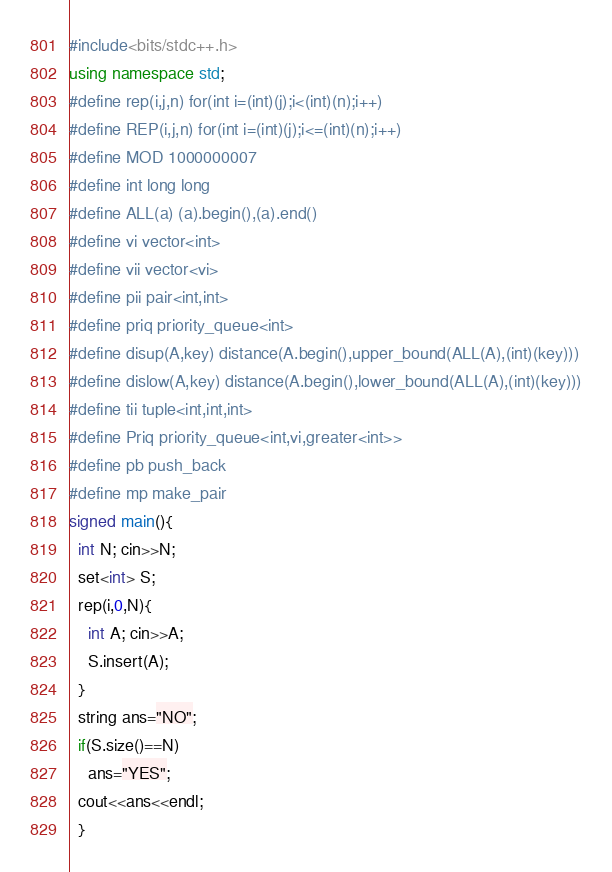Convert code to text. <code><loc_0><loc_0><loc_500><loc_500><_C++_>#include<bits/stdc++.h>
using namespace std;
#define rep(i,j,n) for(int i=(int)(j);i<(int)(n);i++)
#define REP(i,j,n) for(int i=(int)(j);i<=(int)(n);i++)
#define MOD 1000000007
#define int long long
#define ALL(a) (a).begin(),(a).end()
#define vi vector<int>
#define vii vector<vi>
#define pii pair<int,int>
#define priq priority_queue<int>
#define disup(A,key) distance(A.begin(),upper_bound(ALL(A),(int)(key)))
#define dislow(A,key) distance(A.begin(),lower_bound(ALL(A),(int)(key)))
#define tii tuple<int,int,int>
#define Priq priority_queue<int,vi,greater<int>>
#define pb push_back
#define mp make_pair
signed main(){
  int N; cin>>N;
  set<int> S;
  rep(i,0,N){
    int A; cin>>A;
    S.insert(A);
  }
  string ans="NO";
  if(S.size()==N)
    ans="YES";
  cout<<ans<<endl;
  }

</code> 